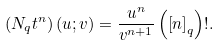Convert formula to latex. <formula><loc_0><loc_0><loc_500><loc_500>\left ( N _ { q } t ^ { n } \right ) \left ( u ; v \right ) = \frac { u ^ { n } } { v ^ { n + 1 } } \left ( \left [ n \right ] _ { q } \right ) ! .</formula> 